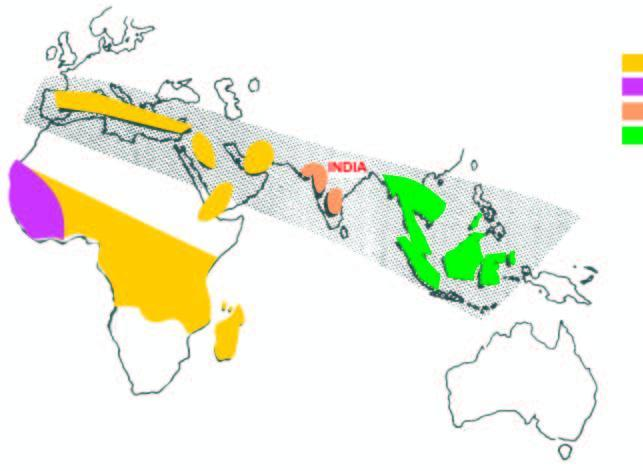how are the haemoglobin and hbd disorders in india?
Answer the question using a single word or phrase. Common 